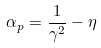Convert formula to latex. <formula><loc_0><loc_0><loc_500><loc_500>\alpha _ { p } = \frac { 1 } { \gamma ^ { 2 } } - \eta</formula> 